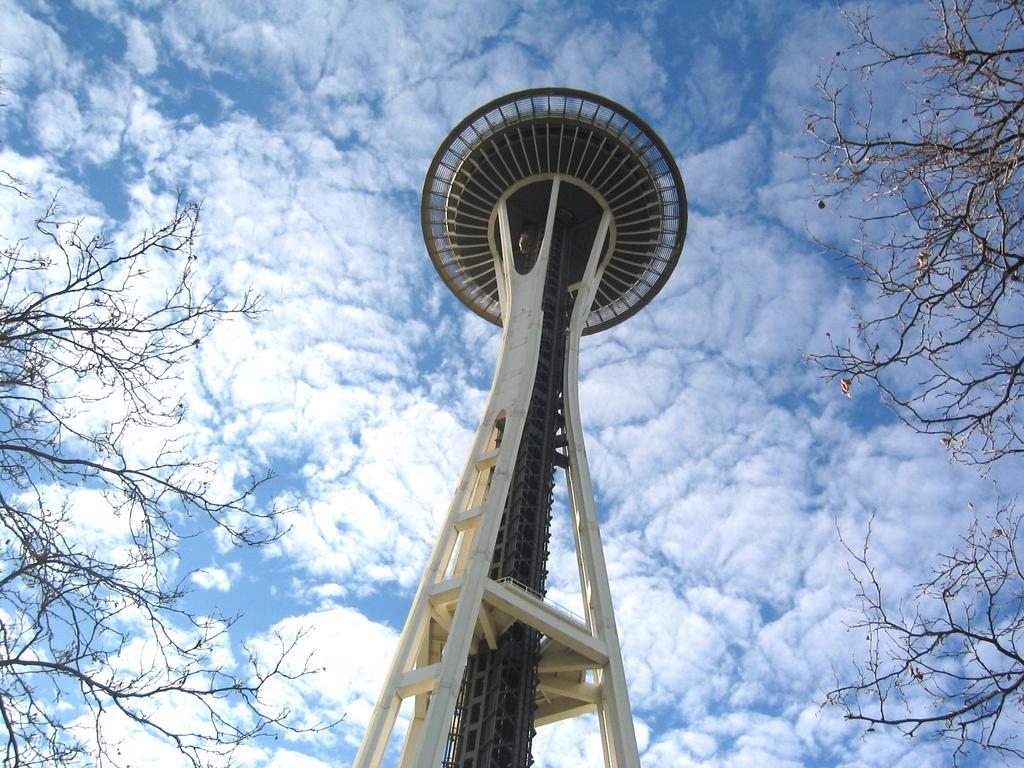Can you describe this image briefly? In this image we can see a tower, there are trees on left and right side of the image and top of the image there is sunny sky. 